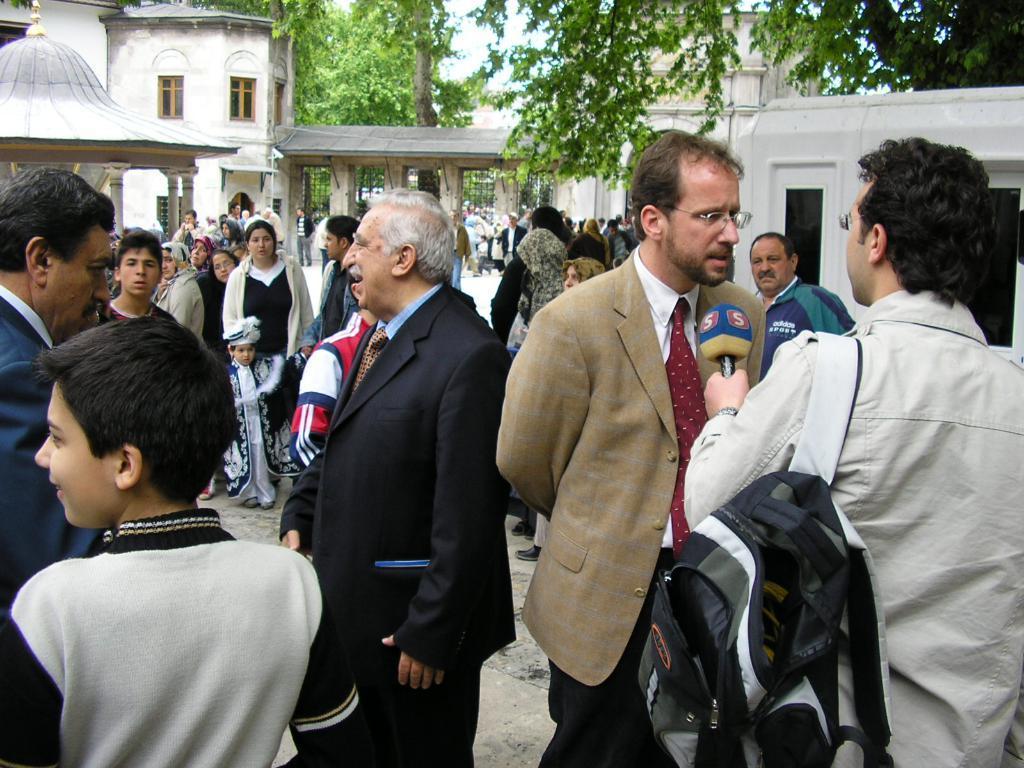Describe this image in one or two sentences. In this picture I can see a group of people in the middle. In the background there are buildings and trees. 